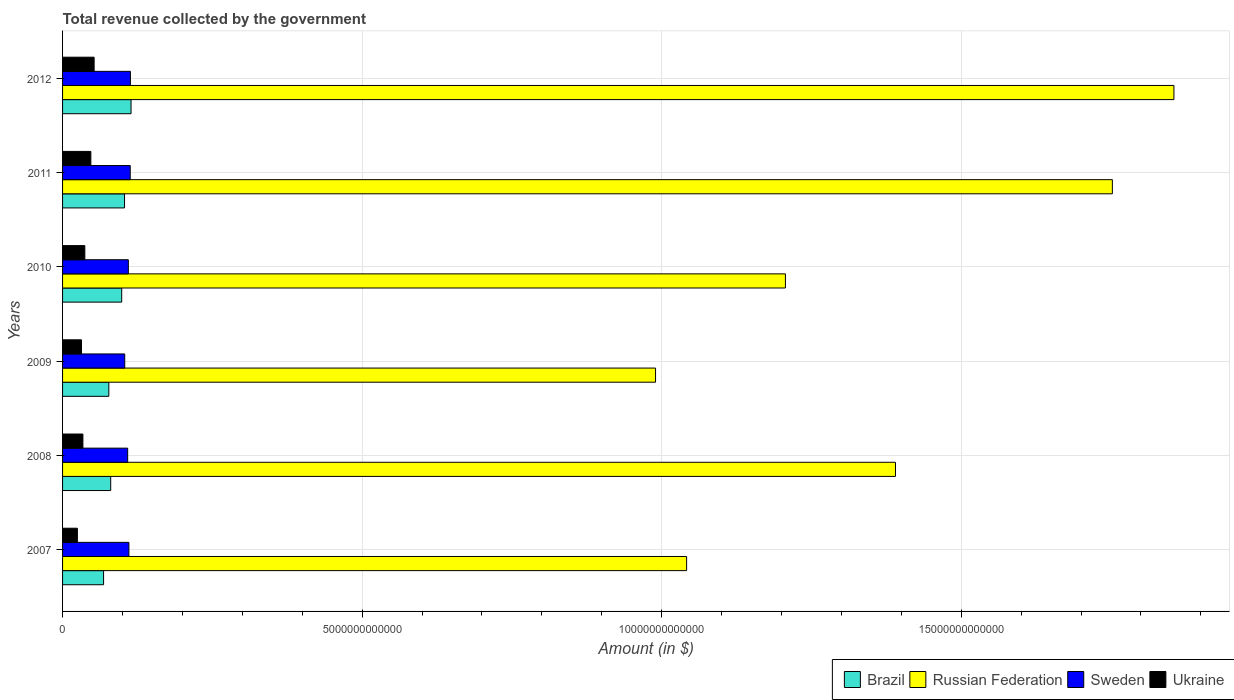How many groups of bars are there?
Offer a terse response. 6. How many bars are there on the 3rd tick from the top?
Your answer should be compact. 4. How many bars are there on the 2nd tick from the bottom?
Your answer should be compact. 4. What is the total revenue collected by the government in Ukraine in 2010?
Provide a short and direct response. 3.72e+11. Across all years, what is the maximum total revenue collected by the government in Russian Federation?
Offer a terse response. 1.85e+13. Across all years, what is the minimum total revenue collected by the government in Russian Federation?
Provide a short and direct response. 9.90e+12. What is the total total revenue collected by the government in Ukraine in the graph?
Provide a succinct answer. 2.27e+12. What is the difference between the total revenue collected by the government in Russian Federation in 2010 and that in 2011?
Make the answer very short. -5.46e+12. What is the difference between the total revenue collected by the government in Sweden in 2009 and the total revenue collected by the government in Ukraine in 2008?
Your answer should be very brief. 6.98e+11. What is the average total revenue collected by the government in Ukraine per year?
Offer a very short reply. 3.79e+11. In the year 2008, what is the difference between the total revenue collected by the government in Brazil and total revenue collected by the government in Russian Federation?
Your response must be concise. -1.31e+13. What is the ratio of the total revenue collected by the government in Sweden in 2007 to that in 2012?
Offer a terse response. 0.98. Is the difference between the total revenue collected by the government in Brazil in 2009 and 2010 greater than the difference between the total revenue collected by the government in Russian Federation in 2009 and 2010?
Ensure brevity in your answer.  Yes. What is the difference between the highest and the second highest total revenue collected by the government in Russian Federation?
Provide a succinct answer. 1.03e+12. What is the difference between the highest and the lowest total revenue collected by the government in Ukraine?
Provide a succinct answer. 2.79e+11. Is it the case that in every year, the sum of the total revenue collected by the government in Brazil and total revenue collected by the government in Russian Federation is greater than the sum of total revenue collected by the government in Ukraine and total revenue collected by the government in Sweden?
Offer a very short reply. No. What does the 1st bar from the top in 2011 represents?
Make the answer very short. Ukraine. What does the 2nd bar from the bottom in 2008 represents?
Provide a succinct answer. Russian Federation. How many bars are there?
Offer a terse response. 24. What is the difference between two consecutive major ticks on the X-axis?
Keep it short and to the point. 5.00e+12. Are the values on the major ticks of X-axis written in scientific E-notation?
Offer a terse response. No. Does the graph contain grids?
Provide a short and direct response. Yes. Where does the legend appear in the graph?
Provide a succinct answer. Bottom right. How many legend labels are there?
Provide a short and direct response. 4. What is the title of the graph?
Keep it short and to the point. Total revenue collected by the government. What is the label or title of the X-axis?
Provide a succinct answer. Amount (in $). What is the label or title of the Y-axis?
Your answer should be very brief. Years. What is the Amount (in $) of Brazil in 2007?
Offer a very short reply. 6.85e+11. What is the Amount (in $) in Russian Federation in 2007?
Give a very brief answer. 1.04e+13. What is the Amount (in $) in Sweden in 2007?
Your response must be concise. 1.11e+12. What is the Amount (in $) of Ukraine in 2007?
Your answer should be compact. 2.47e+11. What is the Amount (in $) of Brazil in 2008?
Give a very brief answer. 8.03e+11. What is the Amount (in $) in Russian Federation in 2008?
Keep it short and to the point. 1.39e+13. What is the Amount (in $) of Sweden in 2008?
Your answer should be compact. 1.09e+12. What is the Amount (in $) of Ukraine in 2008?
Offer a very short reply. 3.40e+11. What is the Amount (in $) in Brazil in 2009?
Make the answer very short. 7.72e+11. What is the Amount (in $) of Russian Federation in 2009?
Give a very brief answer. 9.90e+12. What is the Amount (in $) of Sweden in 2009?
Offer a terse response. 1.04e+12. What is the Amount (in $) in Ukraine in 2009?
Offer a terse response. 3.16e+11. What is the Amount (in $) in Brazil in 2010?
Your answer should be very brief. 9.87e+11. What is the Amount (in $) of Russian Federation in 2010?
Offer a terse response. 1.21e+13. What is the Amount (in $) of Sweden in 2010?
Your answer should be compact. 1.10e+12. What is the Amount (in $) of Ukraine in 2010?
Provide a short and direct response. 3.72e+11. What is the Amount (in $) in Brazil in 2011?
Ensure brevity in your answer.  1.03e+12. What is the Amount (in $) in Russian Federation in 2011?
Your answer should be compact. 1.75e+13. What is the Amount (in $) of Sweden in 2011?
Make the answer very short. 1.13e+12. What is the Amount (in $) of Ukraine in 2011?
Provide a short and direct response. 4.72e+11. What is the Amount (in $) in Brazil in 2012?
Ensure brevity in your answer.  1.14e+12. What is the Amount (in $) of Russian Federation in 2012?
Provide a short and direct response. 1.85e+13. What is the Amount (in $) in Sweden in 2012?
Keep it short and to the point. 1.13e+12. What is the Amount (in $) of Ukraine in 2012?
Give a very brief answer. 5.27e+11. Across all years, what is the maximum Amount (in $) in Brazil?
Your response must be concise. 1.14e+12. Across all years, what is the maximum Amount (in $) in Russian Federation?
Make the answer very short. 1.85e+13. Across all years, what is the maximum Amount (in $) of Sweden?
Your answer should be compact. 1.13e+12. Across all years, what is the maximum Amount (in $) of Ukraine?
Your response must be concise. 5.27e+11. Across all years, what is the minimum Amount (in $) in Brazil?
Make the answer very short. 6.85e+11. Across all years, what is the minimum Amount (in $) in Russian Federation?
Keep it short and to the point. 9.90e+12. Across all years, what is the minimum Amount (in $) in Sweden?
Ensure brevity in your answer.  1.04e+12. Across all years, what is the minimum Amount (in $) of Ukraine?
Your answer should be compact. 2.47e+11. What is the total Amount (in $) in Brazil in the graph?
Make the answer very short. 5.42e+12. What is the total Amount (in $) in Russian Federation in the graph?
Keep it short and to the point. 8.24e+13. What is the total Amount (in $) of Sweden in the graph?
Make the answer very short. 6.59e+12. What is the total Amount (in $) of Ukraine in the graph?
Offer a very short reply. 2.27e+12. What is the difference between the Amount (in $) in Brazil in 2007 and that in 2008?
Provide a short and direct response. -1.19e+11. What is the difference between the Amount (in $) in Russian Federation in 2007 and that in 2008?
Provide a short and direct response. -3.49e+12. What is the difference between the Amount (in $) of Sweden in 2007 and that in 2008?
Offer a terse response. 2.05e+1. What is the difference between the Amount (in $) of Ukraine in 2007 and that in 2008?
Ensure brevity in your answer.  -9.23e+1. What is the difference between the Amount (in $) of Brazil in 2007 and that in 2009?
Provide a short and direct response. -8.77e+1. What is the difference between the Amount (in $) in Russian Federation in 2007 and that in 2009?
Keep it short and to the point. 5.18e+11. What is the difference between the Amount (in $) in Sweden in 2007 and that in 2009?
Offer a very short reply. 6.95e+1. What is the difference between the Amount (in $) of Ukraine in 2007 and that in 2009?
Give a very brief answer. -6.84e+1. What is the difference between the Amount (in $) of Brazil in 2007 and that in 2010?
Your answer should be very brief. -3.03e+11. What is the difference between the Amount (in $) of Russian Federation in 2007 and that in 2010?
Provide a short and direct response. -1.65e+12. What is the difference between the Amount (in $) in Sweden in 2007 and that in 2010?
Offer a very short reply. 9.18e+09. What is the difference between the Amount (in $) of Ukraine in 2007 and that in 2010?
Keep it short and to the point. -1.24e+11. What is the difference between the Amount (in $) in Brazil in 2007 and that in 2011?
Provide a succinct answer. -3.50e+11. What is the difference between the Amount (in $) in Russian Federation in 2007 and that in 2011?
Your response must be concise. -7.11e+12. What is the difference between the Amount (in $) of Sweden in 2007 and that in 2011?
Keep it short and to the point. -2.20e+1. What is the difference between the Amount (in $) in Ukraine in 2007 and that in 2011?
Provide a short and direct response. -2.25e+11. What is the difference between the Amount (in $) of Brazil in 2007 and that in 2012?
Offer a terse response. -4.58e+11. What is the difference between the Amount (in $) in Russian Federation in 2007 and that in 2012?
Provide a succinct answer. -8.13e+12. What is the difference between the Amount (in $) in Sweden in 2007 and that in 2012?
Provide a short and direct response. -2.51e+1. What is the difference between the Amount (in $) of Ukraine in 2007 and that in 2012?
Make the answer very short. -2.79e+11. What is the difference between the Amount (in $) in Brazil in 2008 and that in 2009?
Your response must be concise. 3.13e+1. What is the difference between the Amount (in $) in Russian Federation in 2008 and that in 2009?
Keep it short and to the point. 4.01e+12. What is the difference between the Amount (in $) of Sweden in 2008 and that in 2009?
Offer a terse response. 4.90e+1. What is the difference between the Amount (in $) of Ukraine in 2008 and that in 2009?
Keep it short and to the point. 2.38e+1. What is the difference between the Amount (in $) of Brazil in 2008 and that in 2010?
Ensure brevity in your answer.  -1.84e+11. What is the difference between the Amount (in $) of Russian Federation in 2008 and that in 2010?
Give a very brief answer. 1.84e+12. What is the difference between the Amount (in $) in Sweden in 2008 and that in 2010?
Your answer should be compact. -1.14e+1. What is the difference between the Amount (in $) of Ukraine in 2008 and that in 2010?
Offer a terse response. -3.21e+1. What is the difference between the Amount (in $) of Brazil in 2008 and that in 2011?
Your answer should be very brief. -2.31e+11. What is the difference between the Amount (in $) in Russian Federation in 2008 and that in 2011?
Your answer should be compact. -3.62e+12. What is the difference between the Amount (in $) of Sweden in 2008 and that in 2011?
Your answer should be very brief. -4.26e+1. What is the difference between the Amount (in $) in Ukraine in 2008 and that in 2011?
Give a very brief answer. -1.32e+11. What is the difference between the Amount (in $) in Brazil in 2008 and that in 2012?
Keep it short and to the point. -3.39e+11. What is the difference between the Amount (in $) in Russian Federation in 2008 and that in 2012?
Provide a short and direct response. -4.65e+12. What is the difference between the Amount (in $) in Sweden in 2008 and that in 2012?
Provide a short and direct response. -4.57e+1. What is the difference between the Amount (in $) of Ukraine in 2008 and that in 2012?
Give a very brief answer. -1.87e+11. What is the difference between the Amount (in $) in Brazil in 2009 and that in 2010?
Ensure brevity in your answer.  -2.15e+11. What is the difference between the Amount (in $) in Russian Federation in 2009 and that in 2010?
Provide a short and direct response. -2.17e+12. What is the difference between the Amount (in $) of Sweden in 2009 and that in 2010?
Your answer should be very brief. -6.03e+1. What is the difference between the Amount (in $) in Ukraine in 2009 and that in 2010?
Ensure brevity in your answer.  -5.59e+1. What is the difference between the Amount (in $) in Brazil in 2009 and that in 2011?
Make the answer very short. -2.62e+11. What is the difference between the Amount (in $) of Russian Federation in 2009 and that in 2011?
Provide a succinct answer. -7.62e+12. What is the difference between the Amount (in $) of Sweden in 2009 and that in 2011?
Your response must be concise. -9.15e+1. What is the difference between the Amount (in $) in Ukraine in 2009 and that in 2011?
Your response must be concise. -1.56e+11. What is the difference between the Amount (in $) of Brazil in 2009 and that in 2012?
Make the answer very short. -3.71e+11. What is the difference between the Amount (in $) of Russian Federation in 2009 and that in 2012?
Your answer should be compact. -8.65e+12. What is the difference between the Amount (in $) of Sweden in 2009 and that in 2012?
Your response must be concise. -9.46e+1. What is the difference between the Amount (in $) of Ukraine in 2009 and that in 2012?
Your answer should be compact. -2.11e+11. What is the difference between the Amount (in $) in Brazil in 2010 and that in 2011?
Keep it short and to the point. -4.72e+1. What is the difference between the Amount (in $) in Russian Federation in 2010 and that in 2011?
Provide a succinct answer. -5.46e+12. What is the difference between the Amount (in $) of Sweden in 2010 and that in 2011?
Give a very brief answer. -3.12e+1. What is the difference between the Amount (in $) of Ukraine in 2010 and that in 2011?
Give a very brief answer. -1.00e+11. What is the difference between the Amount (in $) in Brazil in 2010 and that in 2012?
Your answer should be compact. -1.56e+11. What is the difference between the Amount (in $) of Russian Federation in 2010 and that in 2012?
Give a very brief answer. -6.48e+12. What is the difference between the Amount (in $) of Sweden in 2010 and that in 2012?
Give a very brief answer. -3.43e+1. What is the difference between the Amount (in $) of Ukraine in 2010 and that in 2012?
Keep it short and to the point. -1.55e+11. What is the difference between the Amount (in $) in Brazil in 2011 and that in 2012?
Provide a succinct answer. -1.09e+11. What is the difference between the Amount (in $) of Russian Federation in 2011 and that in 2012?
Make the answer very short. -1.03e+12. What is the difference between the Amount (in $) of Sweden in 2011 and that in 2012?
Your answer should be compact. -3.11e+09. What is the difference between the Amount (in $) in Ukraine in 2011 and that in 2012?
Provide a succinct answer. -5.46e+1. What is the difference between the Amount (in $) of Brazil in 2007 and the Amount (in $) of Russian Federation in 2008?
Your answer should be compact. -1.32e+13. What is the difference between the Amount (in $) in Brazil in 2007 and the Amount (in $) in Sweden in 2008?
Ensure brevity in your answer.  -4.02e+11. What is the difference between the Amount (in $) of Brazil in 2007 and the Amount (in $) of Ukraine in 2008?
Provide a succinct answer. 3.45e+11. What is the difference between the Amount (in $) in Russian Federation in 2007 and the Amount (in $) in Sweden in 2008?
Ensure brevity in your answer.  9.33e+12. What is the difference between the Amount (in $) in Russian Federation in 2007 and the Amount (in $) in Ukraine in 2008?
Your answer should be very brief. 1.01e+13. What is the difference between the Amount (in $) in Sweden in 2007 and the Amount (in $) in Ukraine in 2008?
Make the answer very short. 7.68e+11. What is the difference between the Amount (in $) in Brazil in 2007 and the Amount (in $) in Russian Federation in 2009?
Keep it short and to the point. -9.21e+12. What is the difference between the Amount (in $) in Brazil in 2007 and the Amount (in $) in Sweden in 2009?
Ensure brevity in your answer.  -3.53e+11. What is the difference between the Amount (in $) of Brazil in 2007 and the Amount (in $) of Ukraine in 2009?
Offer a terse response. 3.69e+11. What is the difference between the Amount (in $) of Russian Federation in 2007 and the Amount (in $) of Sweden in 2009?
Give a very brief answer. 9.38e+12. What is the difference between the Amount (in $) in Russian Federation in 2007 and the Amount (in $) in Ukraine in 2009?
Your answer should be very brief. 1.01e+13. What is the difference between the Amount (in $) of Sweden in 2007 and the Amount (in $) of Ukraine in 2009?
Offer a terse response. 7.91e+11. What is the difference between the Amount (in $) in Brazil in 2007 and the Amount (in $) in Russian Federation in 2010?
Give a very brief answer. -1.14e+13. What is the difference between the Amount (in $) in Brazil in 2007 and the Amount (in $) in Sweden in 2010?
Provide a succinct answer. -4.13e+11. What is the difference between the Amount (in $) of Brazil in 2007 and the Amount (in $) of Ukraine in 2010?
Provide a short and direct response. 3.13e+11. What is the difference between the Amount (in $) of Russian Federation in 2007 and the Amount (in $) of Sweden in 2010?
Ensure brevity in your answer.  9.32e+12. What is the difference between the Amount (in $) in Russian Federation in 2007 and the Amount (in $) in Ukraine in 2010?
Your response must be concise. 1.00e+13. What is the difference between the Amount (in $) of Sweden in 2007 and the Amount (in $) of Ukraine in 2010?
Ensure brevity in your answer.  7.36e+11. What is the difference between the Amount (in $) in Brazil in 2007 and the Amount (in $) in Russian Federation in 2011?
Offer a terse response. -1.68e+13. What is the difference between the Amount (in $) of Brazil in 2007 and the Amount (in $) of Sweden in 2011?
Your answer should be very brief. -4.45e+11. What is the difference between the Amount (in $) in Brazil in 2007 and the Amount (in $) in Ukraine in 2011?
Your answer should be very brief. 2.12e+11. What is the difference between the Amount (in $) in Russian Federation in 2007 and the Amount (in $) in Sweden in 2011?
Provide a succinct answer. 9.29e+12. What is the difference between the Amount (in $) of Russian Federation in 2007 and the Amount (in $) of Ukraine in 2011?
Your answer should be very brief. 9.94e+12. What is the difference between the Amount (in $) of Sweden in 2007 and the Amount (in $) of Ukraine in 2011?
Provide a succinct answer. 6.35e+11. What is the difference between the Amount (in $) of Brazil in 2007 and the Amount (in $) of Russian Federation in 2012?
Provide a succinct answer. -1.79e+13. What is the difference between the Amount (in $) in Brazil in 2007 and the Amount (in $) in Sweden in 2012?
Keep it short and to the point. -4.48e+11. What is the difference between the Amount (in $) of Brazil in 2007 and the Amount (in $) of Ukraine in 2012?
Offer a very short reply. 1.58e+11. What is the difference between the Amount (in $) of Russian Federation in 2007 and the Amount (in $) of Sweden in 2012?
Offer a terse response. 9.28e+12. What is the difference between the Amount (in $) in Russian Federation in 2007 and the Amount (in $) in Ukraine in 2012?
Offer a very short reply. 9.89e+12. What is the difference between the Amount (in $) in Sweden in 2007 and the Amount (in $) in Ukraine in 2012?
Give a very brief answer. 5.81e+11. What is the difference between the Amount (in $) of Brazil in 2008 and the Amount (in $) of Russian Federation in 2009?
Your answer should be compact. -9.09e+12. What is the difference between the Amount (in $) of Brazil in 2008 and the Amount (in $) of Sweden in 2009?
Ensure brevity in your answer.  -2.34e+11. What is the difference between the Amount (in $) of Brazil in 2008 and the Amount (in $) of Ukraine in 2009?
Your answer should be very brief. 4.88e+11. What is the difference between the Amount (in $) of Russian Federation in 2008 and the Amount (in $) of Sweden in 2009?
Your answer should be very brief. 1.29e+13. What is the difference between the Amount (in $) of Russian Federation in 2008 and the Amount (in $) of Ukraine in 2009?
Provide a succinct answer. 1.36e+13. What is the difference between the Amount (in $) in Sweden in 2008 and the Amount (in $) in Ukraine in 2009?
Your response must be concise. 7.71e+11. What is the difference between the Amount (in $) of Brazil in 2008 and the Amount (in $) of Russian Federation in 2010?
Your response must be concise. -1.13e+13. What is the difference between the Amount (in $) in Brazil in 2008 and the Amount (in $) in Sweden in 2010?
Keep it short and to the point. -2.95e+11. What is the difference between the Amount (in $) of Brazil in 2008 and the Amount (in $) of Ukraine in 2010?
Your response must be concise. 4.32e+11. What is the difference between the Amount (in $) of Russian Federation in 2008 and the Amount (in $) of Sweden in 2010?
Make the answer very short. 1.28e+13. What is the difference between the Amount (in $) of Russian Federation in 2008 and the Amount (in $) of Ukraine in 2010?
Ensure brevity in your answer.  1.35e+13. What is the difference between the Amount (in $) of Sweden in 2008 and the Amount (in $) of Ukraine in 2010?
Offer a terse response. 7.15e+11. What is the difference between the Amount (in $) in Brazil in 2008 and the Amount (in $) in Russian Federation in 2011?
Offer a very short reply. -1.67e+13. What is the difference between the Amount (in $) in Brazil in 2008 and the Amount (in $) in Sweden in 2011?
Make the answer very short. -3.26e+11. What is the difference between the Amount (in $) in Brazil in 2008 and the Amount (in $) in Ukraine in 2011?
Provide a succinct answer. 3.31e+11. What is the difference between the Amount (in $) of Russian Federation in 2008 and the Amount (in $) of Sweden in 2011?
Your answer should be compact. 1.28e+13. What is the difference between the Amount (in $) of Russian Federation in 2008 and the Amount (in $) of Ukraine in 2011?
Offer a very short reply. 1.34e+13. What is the difference between the Amount (in $) of Sweden in 2008 and the Amount (in $) of Ukraine in 2011?
Provide a succinct answer. 6.15e+11. What is the difference between the Amount (in $) in Brazil in 2008 and the Amount (in $) in Russian Federation in 2012?
Ensure brevity in your answer.  -1.77e+13. What is the difference between the Amount (in $) of Brazil in 2008 and the Amount (in $) of Sweden in 2012?
Provide a succinct answer. -3.29e+11. What is the difference between the Amount (in $) in Brazil in 2008 and the Amount (in $) in Ukraine in 2012?
Your answer should be compact. 2.77e+11. What is the difference between the Amount (in $) in Russian Federation in 2008 and the Amount (in $) in Sweden in 2012?
Keep it short and to the point. 1.28e+13. What is the difference between the Amount (in $) in Russian Federation in 2008 and the Amount (in $) in Ukraine in 2012?
Your answer should be very brief. 1.34e+13. What is the difference between the Amount (in $) of Sweden in 2008 and the Amount (in $) of Ukraine in 2012?
Your answer should be compact. 5.60e+11. What is the difference between the Amount (in $) in Brazil in 2009 and the Amount (in $) in Russian Federation in 2010?
Provide a short and direct response. -1.13e+13. What is the difference between the Amount (in $) of Brazil in 2009 and the Amount (in $) of Sweden in 2010?
Your answer should be compact. -3.26e+11. What is the difference between the Amount (in $) of Brazil in 2009 and the Amount (in $) of Ukraine in 2010?
Offer a terse response. 4.01e+11. What is the difference between the Amount (in $) in Russian Federation in 2009 and the Amount (in $) in Sweden in 2010?
Offer a very short reply. 8.80e+12. What is the difference between the Amount (in $) in Russian Federation in 2009 and the Amount (in $) in Ukraine in 2010?
Your response must be concise. 9.53e+12. What is the difference between the Amount (in $) in Sweden in 2009 and the Amount (in $) in Ukraine in 2010?
Offer a very short reply. 6.66e+11. What is the difference between the Amount (in $) in Brazil in 2009 and the Amount (in $) in Russian Federation in 2011?
Provide a short and direct response. -1.68e+13. What is the difference between the Amount (in $) in Brazil in 2009 and the Amount (in $) in Sweden in 2011?
Provide a short and direct response. -3.57e+11. What is the difference between the Amount (in $) in Brazil in 2009 and the Amount (in $) in Ukraine in 2011?
Your answer should be very brief. 3.00e+11. What is the difference between the Amount (in $) in Russian Federation in 2009 and the Amount (in $) in Sweden in 2011?
Provide a short and direct response. 8.77e+12. What is the difference between the Amount (in $) of Russian Federation in 2009 and the Amount (in $) of Ukraine in 2011?
Keep it short and to the point. 9.43e+12. What is the difference between the Amount (in $) of Sweden in 2009 and the Amount (in $) of Ukraine in 2011?
Give a very brief answer. 5.66e+11. What is the difference between the Amount (in $) of Brazil in 2009 and the Amount (in $) of Russian Federation in 2012?
Your response must be concise. -1.78e+13. What is the difference between the Amount (in $) of Brazil in 2009 and the Amount (in $) of Sweden in 2012?
Ensure brevity in your answer.  -3.60e+11. What is the difference between the Amount (in $) in Brazil in 2009 and the Amount (in $) in Ukraine in 2012?
Offer a terse response. 2.46e+11. What is the difference between the Amount (in $) in Russian Federation in 2009 and the Amount (in $) in Sweden in 2012?
Provide a short and direct response. 8.77e+12. What is the difference between the Amount (in $) of Russian Federation in 2009 and the Amount (in $) of Ukraine in 2012?
Give a very brief answer. 9.37e+12. What is the difference between the Amount (in $) of Sweden in 2009 and the Amount (in $) of Ukraine in 2012?
Offer a terse response. 5.11e+11. What is the difference between the Amount (in $) of Brazil in 2010 and the Amount (in $) of Russian Federation in 2011?
Your response must be concise. -1.65e+13. What is the difference between the Amount (in $) of Brazil in 2010 and the Amount (in $) of Sweden in 2011?
Give a very brief answer. -1.42e+11. What is the difference between the Amount (in $) of Brazil in 2010 and the Amount (in $) of Ukraine in 2011?
Give a very brief answer. 5.15e+11. What is the difference between the Amount (in $) in Russian Federation in 2010 and the Amount (in $) in Sweden in 2011?
Ensure brevity in your answer.  1.09e+13. What is the difference between the Amount (in $) in Russian Federation in 2010 and the Amount (in $) in Ukraine in 2011?
Your answer should be very brief. 1.16e+13. What is the difference between the Amount (in $) of Sweden in 2010 and the Amount (in $) of Ukraine in 2011?
Your response must be concise. 6.26e+11. What is the difference between the Amount (in $) in Brazil in 2010 and the Amount (in $) in Russian Federation in 2012?
Offer a terse response. -1.76e+13. What is the difference between the Amount (in $) of Brazil in 2010 and the Amount (in $) of Sweden in 2012?
Offer a terse response. -1.45e+11. What is the difference between the Amount (in $) in Brazil in 2010 and the Amount (in $) in Ukraine in 2012?
Provide a succinct answer. 4.61e+11. What is the difference between the Amount (in $) in Russian Federation in 2010 and the Amount (in $) in Sweden in 2012?
Your answer should be compact. 1.09e+13. What is the difference between the Amount (in $) of Russian Federation in 2010 and the Amount (in $) of Ukraine in 2012?
Ensure brevity in your answer.  1.15e+13. What is the difference between the Amount (in $) in Sweden in 2010 and the Amount (in $) in Ukraine in 2012?
Offer a terse response. 5.71e+11. What is the difference between the Amount (in $) of Brazil in 2011 and the Amount (in $) of Russian Federation in 2012?
Keep it short and to the point. -1.75e+13. What is the difference between the Amount (in $) in Brazil in 2011 and the Amount (in $) in Sweden in 2012?
Offer a terse response. -9.79e+1. What is the difference between the Amount (in $) in Brazil in 2011 and the Amount (in $) in Ukraine in 2012?
Make the answer very short. 5.08e+11. What is the difference between the Amount (in $) in Russian Federation in 2011 and the Amount (in $) in Sweden in 2012?
Your answer should be very brief. 1.64e+13. What is the difference between the Amount (in $) in Russian Federation in 2011 and the Amount (in $) in Ukraine in 2012?
Provide a succinct answer. 1.70e+13. What is the difference between the Amount (in $) of Sweden in 2011 and the Amount (in $) of Ukraine in 2012?
Make the answer very short. 6.03e+11. What is the average Amount (in $) of Brazil per year?
Make the answer very short. 9.04e+11. What is the average Amount (in $) of Russian Federation per year?
Your answer should be very brief. 1.37e+13. What is the average Amount (in $) of Sweden per year?
Provide a succinct answer. 1.10e+12. What is the average Amount (in $) in Ukraine per year?
Your answer should be compact. 3.79e+11. In the year 2007, what is the difference between the Amount (in $) of Brazil and Amount (in $) of Russian Federation?
Give a very brief answer. -9.73e+12. In the year 2007, what is the difference between the Amount (in $) in Brazil and Amount (in $) in Sweden?
Offer a very short reply. -4.23e+11. In the year 2007, what is the difference between the Amount (in $) of Brazil and Amount (in $) of Ukraine?
Offer a very short reply. 4.37e+11. In the year 2007, what is the difference between the Amount (in $) in Russian Federation and Amount (in $) in Sweden?
Your response must be concise. 9.31e+12. In the year 2007, what is the difference between the Amount (in $) in Russian Federation and Amount (in $) in Ukraine?
Give a very brief answer. 1.02e+13. In the year 2007, what is the difference between the Amount (in $) in Sweden and Amount (in $) in Ukraine?
Your answer should be very brief. 8.60e+11. In the year 2008, what is the difference between the Amount (in $) of Brazil and Amount (in $) of Russian Federation?
Make the answer very short. -1.31e+13. In the year 2008, what is the difference between the Amount (in $) of Brazil and Amount (in $) of Sweden?
Offer a very short reply. -2.83e+11. In the year 2008, what is the difference between the Amount (in $) in Brazil and Amount (in $) in Ukraine?
Keep it short and to the point. 4.64e+11. In the year 2008, what is the difference between the Amount (in $) of Russian Federation and Amount (in $) of Sweden?
Give a very brief answer. 1.28e+13. In the year 2008, what is the difference between the Amount (in $) of Russian Federation and Amount (in $) of Ukraine?
Your answer should be very brief. 1.36e+13. In the year 2008, what is the difference between the Amount (in $) of Sweden and Amount (in $) of Ukraine?
Keep it short and to the point. 7.47e+11. In the year 2009, what is the difference between the Amount (in $) in Brazil and Amount (in $) in Russian Federation?
Keep it short and to the point. -9.13e+12. In the year 2009, what is the difference between the Amount (in $) of Brazil and Amount (in $) of Sweden?
Make the answer very short. -2.65e+11. In the year 2009, what is the difference between the Amount (in $) of Brazil and Amount (in $) of Ukraine?
Offer a terse response. 4.56e+11. In the year 2009, what is the difference between the Amount (in $) in Russian Federation and Amount (in $) in Sweden?
Give a very brief answer. 8.86e+12. In the year 2009, what is the difference between the Amount (in $) of Russian Federation and Amount (in $) of Ukraine?
Your answer should be compact. 9.58e+12. In the year 2009, what is the difference between the Amount (in $) in Sweden and Amount (in $) in Ukraine?
Your response must be concise. 7.22e+11. In the year 2010, what is the difference between the Amount (in $) of Brazil and Amount (in $) of Russian Federation?
Your answer should be compact. -1.11e+13. In the year 2010, what is the difference between the Amount (in $) of Brazil and Amount (in $) of Sweden?
Ensure brevity in your answer.  -1.11e+11. In the year 2010, what is the difference between the Amount (in $) in Brazil and Amount (in $) in Ukraine?
Your response must be concise. 6.15e+11. In the year 2010, what is the difference between the Amount (in $) of Russian Federation and Amount (in $) of Sweden?
Your response must be concise. 1.10e+13. In the year 2010, what is the difference between the Amount (in $) in Russian Federation and Amount (in $) in Ukraine?
Provide a succinct answer. 1.17e+13. In the year 2010, what is the difference between the Amount (in $) of Sweden and Amount (in $) of Ukraine?
Make the answer very short. 7.26e+11. In the year 2011, what is the difference between the Amount (in $) in Brazil and Amount (in $) in Russian Federation?
Give a very brief answer. -1.65e+13. In the year 2011, what is the difference between the Amount (in $) of Brazil and Amount (in $) of Sweden?
Your response must be concise. -9.48e+1. In the year 2011, what is the difference between the Amount (in $) of Brazil and Amount (in $) of Ukraine?
Your answer should be very brief. 5.62e+11. In the year 2011, what is the difference between the Amount (in $) in Russian Federation and Amount (in $) in Sweden?
Provide a short and direct response. 1.64e+13. In the year 2011, what is the difference between the Amount (in $) in Russian Federation and Amount (in $) in Ukraine?
Your answer should be very brief. 1.71e+13. In the year 2011, what is the difference between the Amount (in $) of Sweden and Amount (in $) of Ukraine?
Keep it short and to the point. 6.57e+11. In the year 2012, what is the difference between the Amount (in $) in Brazil and Amount (in $) in Russian Federation?
Offer a terse response. -1.74e+13. In the year 2012, what is the difference between the Amount (in $) in Brazil and Amount (in $) in Sweden?
Give a very brief answer. 1.06e+1. In the year 2012, what is the difference between the Amount (in $) of Brazil and Amount (in $) of Ukraine?
Provide a short and direct response. 6.16e+11. In the year 2012, what is the difference between the Amount (in $) in Russian Federation and Amount (in $) in Sweden?
Your answer should be very brief. 1.74e+13. In the year 2012, what is the difference between the Amount (in $) of Russian Federation and Amount (in $) of Ukraine?
Ensure brevity in your answer.  1.80e+13. In the year 2012, what is the difference between the Amount (in $) of Sweden and Amount (in $) of Ukraine?
Your answer should be very brief. 6.06e+11. What is the ratio of the Amount (in $) in Brazil in 2007 to that in 2008?
Make the answer very short. 0.85. What is the ratio of the Amount (in $) of Russian Federation in 2007 to that in 2008?
Give a very brief answer. 0.75. What is the ratio of the Amount (in $) of Sweden in 2007 to that in 2008?
Provide a short and direct response. 1.02. What is the ratio of the Amount (in $) in Ukraine in 2007 to that in 2008?
Offer a terse response. 0.73. What is the ratio of the Amount (in $) in Brazil in 2007 to that in 2009?
Offer a terse response. 0.89. What is the ratio of the Amount (in $) of Russian Federation in 2007 to that in 2009?
Your response must be concise. 1.05. What is the ratio of the Amount (in $) of Sweden in 2007 to that in 2009?
Ensure brevity in your answer.  1.07. What is the ratio of the Amount (in $) in Ukraine in 2007 to that in 2009?
Offer a very short reply. 0.78. What is the ratio of the Amount (in $) of Brazil in 2007 to that in 2010?
Provide a succinct answer. 0.69. What is the ratio of the Amount (in $) of Russian Federation in 2007 to that in 2010?
Offer a terse response. 0.86. What is the ratio of the Amount (in $) in Sweden in 2007 to that in 2010?
Provide a succinct answer. 1.01. What is the ratio of the Amount (in $) of Ukraine in 2007 to that in 2010?
Keep it short and to the point. 0.67. What is the ratio of the Amount (in $) of Brazil in 2007 to that in 2011?
Give a very brief answer. 0.66. What is the ratio of the Amount (in $) of Russian Federation in 2007 to that in 2011?
Offer a very short reply. 0.59. What is the ratio of the Amount (in $) of Sweden in 2007 to that in 2011?
Keep it short and to the point. 0.98. What is the ratio of the Amount (in $) of Ukraine in 2007 to that in 2011?
Your response must be concise. 0.52. What is the ratio of the Amount (in $) in Brazil in 2007 to that in 2012?
Provide a short and direct response. 0.6. What is the ratio of the Amount (in $) in Russian Federation in 2007 to that in 2012?
Keep it short and to the point. 0.56. What is the ratio of the Amount (in $) in Sweden in 2007 to that in 2012?
Offer a very short reply. 0.98. What is the ratio of the Amount (in $) of Ukraine in 2007 to that in 2012?
Your answer should be very brief. 0.47. What is the ratio of the Amount (in $) of Brazil in 2008 to that in 2009?
Give a very brief answer. 1.04. What is the ratio of the Amount (in $) in Russian Federation in 2008 to that in 2009?
Your response must be concise. 1.4. What is the ratio of the Amount (in $) in Sweden in 2008 to that in 2009?
Keep it short and to the point. 1.05. What is the ratio of the Amount (in $) of Ukraine in 2008 to that in 2009?
Offer a terse response. 1.08. What is the ratio of the Amount (in $) of Brazil in 2008 to that in 2010?
Provide a succinct answer. 0.81. What is the ratio of the Amount (in $) of Russian Federation in 2008 to that in 2010?
Provide a succinct answer. 1.15. What is the ratio of the Amount (in $) in Ukraine in 2008 to that in 2010?
Provide a succinct answer. 0.91. What is the ratio of the Amount (in $) in Brazil in 2008 to that in 2011?
Offer a terse response. 0.78. What is the ratio of the Amount (in $) of Russian Federation in 2008 to that in 2011?
Your answer should be compact. 0.79. What is the ratio of the Amount (in $) of Sweden in 2008 to that in 2011?
Provide a short and direct response. 0.96. What is the ratio of the Amount (in $) of Ukraine in 2008 to that in 2011?
Offer a very short reply. 0.72. What is the ratio of the Amount (in $) in Brazil in 2008 to that in 2012?
Offer a very short reply. 0.7. What is the ratio of the Amount (in $) in Russian Federation in 2008 to that in 2012?
Give a very brief answer. 0.75. What is the ratio of the Amount (in $) in Sweden in 2008 to that in 2012?
Your answer should be compact. 0.96. What is the ratio of the Amount (in $) in Ukraine in 2008 to that in 2012?
Provide a short and direct response. 0.64. What is the ratio of the Amount (in $) in Brazil in 2009 to that in 2010?
Make the answer very short. 0.78. What is the ratio of the Amount (in $) of Russian Federation in 2009 to that in 2010?
Ensure brevity in your answer.  0.82. What is the ratio of the Amount (in $) in Sweden in 2009 to that in 2010?
Offer a very short reply. 0.95. What is the ratio of the Amount (in $) of Ukraine in 2009 to that in 2010?
Your answer should be compact. 0.85. What is the ratio of the Amount (in $) of Brazil in 2009 to that in 2011?
Your response must be concise. 0.75. What is the ratio of the Amount (in $) of Russian Federation in 2009 to that in 2011?
Your response must be concise. 0.56. What is the ratio of the Amount (in $) in Sweden in 2009 to that in 2011?
Your answer should be compact. 0.92. What is the ratio of the Amount (in $) of Ukraine in 2009 to that in 2011?
Give a very brief answer. 0.67. What is the ratio of the Amount (in $) of Brazil in 2009 to that in 2012?
Provide a succinct answer. 0.68. What is the ratio of the Amount (in $) of Russian Federation in 2009 to that in 2012?
Your response must be concise. 0.53. What is the ratio of the Amount (in $) of Sweden in 2009 to that in 2012?
Your answer should be compact. 0.92. What is the ratio of the Amount (in $) in Ukraine in 2009 to that in 2012?
Provide a short and direct response. 0.6. What is the ratio of the Amount (in $) of Brazil in 2010 to that in 2011?
Keep it short and to the point. 0.95. What is the ratio of the Amount (in $) in Russian Federation in 2010 to that in 2011?
Keep it short and to the point. 0.69. What is the ratio of the Amount (in $) in Sweden in 2010 to that in 2011?
Offer a terse response. 0.97. What is the ratio of the Amount (in $) of Ukraine in 2010 to that in 2011?
Your answer should be compact. 0.79. What is the ratio of the Amount (in $) in Brazil in 2010 to that in 2012?
Provide a succinct answer. 0.86. What is the ratio of the Amount (in $) of Russian Federation in 2010 to that in 2012?
Offer a terse response. 0.65. What is the ratio of the Amount (in $) of Sweden in 2010 to that in 2012?
Your answer should be very brief. 0.97. What is the ratio of the Amount (in $) of Ukraine in 2010 to that in 2012?
Provide a short and direct response. 0.71. What is the ratio of the Amount (in $) of Brazil in 2011 to that in 2012?
Your answer should be very brief. 0.91. What is the ratio of the Amount (in $) in Russian Federation in 2011 to that in 2012?
Ensure brevity in your answer.  0.94. What is the ratio of the Amount (in $) of Ukraine in 2011 to that in 2012?
Your answer should be very brief. 0.9. What is the difference between the highest and the second highest Amount (in $) of Brazil?
Offer a terse response. 1.09e+11. What is the difference between the highest and the second highest Amount (in $) in Russian Federation?
Your answer should be compact. 1.03e+12. What is the difference between the highest and the second highest Amount (in $) in Sweden?
Your answer should be very brief. 3.11e+09. What is the difference between the highest and the second highest Amount (in $) of Ukraine?
Make the answer very short. 5.46e+1. What is the difference between the highest and the lowest Amount (in $) in Brazil?
Your response must be concise. 4.58e+11. What is the difference between the highest and the lowest Amount (in $) in Russian Federation?
Your answer should be very brief. 8.65e+12. What is the difference between the highest and the lowest Amount (in $) in Sweden?
Your answer should be very brief. 9.46e+1. What is the difference between the highest and the lowest Amount (in $) of Ukraine?
Offer a terse response. 2.79e+11. 